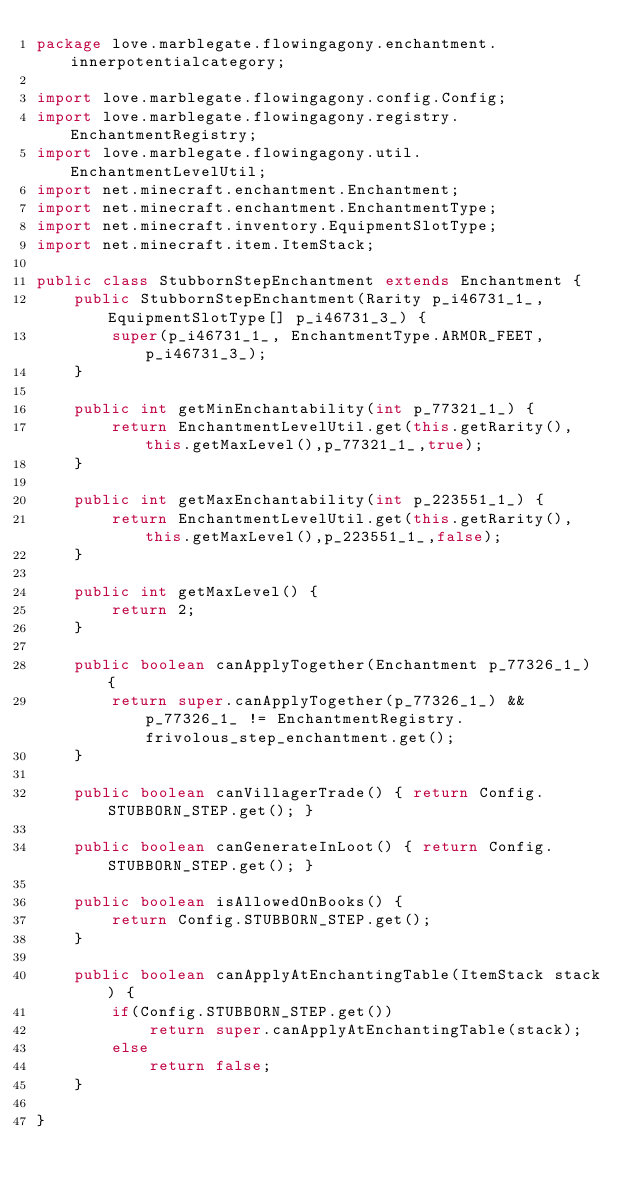<code> <loc_0><loc_0><loc_500><loc_500><_Java_>package love.marblegate.flowingagony.enchantment.innerpotentialcategory;

import love.marblegate.flowingagony.config.Config;
import love.marblegate.flowingagony.registry.EnchantmentRegistry;
import love.marblegate.flowingagony.util.EnchantmentLevelUtil;
import net.minecraft.enchantment.Enchantment;
import net.minecraft.enchantment.EnchantmentType;
import net.minecraft.inventory.EquipmentSlotType;
import net.minecraft.item.ItemStack;

public class StubbornStepEnchantment extends Enchantment {
    public StubbornStepEnchantment(Rarity p_i46731_1_, EquipmentSlotType[] p_i46731_3_) {
        super(p_i46731_1_, EnchantmentType.ARMOR_FEET, p_i46731_3_);
    }

    public int getMinEnchantability(int p_77321_1_) {
        return EnchantmentLevelUtil.get(this.getRarity(),this.getMaxLevel(),p_77321_1_,true);
    }

    public int getMaxEnchantability(int p_223551_1_) {
        return EnchantmentLevelUtil.get(this.getRarity(),this.getMaxLevel(),p_223551_1_,false);
    }

    public int getMaxLevel() {
        return 2;
    }

    public boolean canApplyTogether(Enchantment p_77326_1_) {
        return super.canApplyTogether(p_77326_1_) && p_77326_1_ != EnchantmentRegistry.frivolous_step_enchantment.get();
    }

    public boolean canVillagerTrade() { return Config.STUBBORN_STEP.get(); }

    public boolean canGenerateInLoot() { return Config.STUBBORN_STEP.get(); }

    public boolean isAllowedOnBooks() {
        return Config.STUBBORN_STEP.get();
    }

    public boolean canApplyAtEnchantingTable(ItemStack stack) {
        if(Config.STUBBORN_STEP.get())
            return super.canApplyAtEnchantingTable(stack);
        else
            return false;
    }

}
</code> 